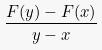<formula> <loc_0><loc_0><loc_500><loc_500>\frac { F ( y ) - F ( x ) } { y - x }</formula> 